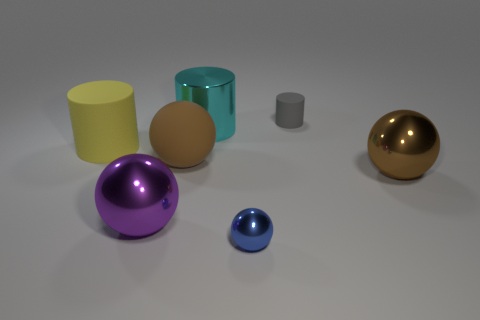The metallic thing that is the same color as the rubber sphere is what shape?
Your answer should be compact. Sphere. Are there more gray rubber cylinders to the right of the tiny gray object than tiny gray matte cylinders?
Offer a terse response. No. How many gray metallic balls are the same size as the cyan thing?
Offer a very short reply. 0. There is a metal ball that is the same color as the large rubber sphere; what is its size?
Keep it short and to the point. Large. How many objects are small metallic objects or large rubber things right of the big yellow rubber object?
Give a very brief answer. 2. The thing that is both to the right of the tiny blue shiny ball and in front of the large matte ball is what color?
Make the answer very short. Brown. Does the metal cylinder have the same size as the purple ball?
Your response must be concise. Yes. There is a large metallic sphere that is on the left side of the blue metal ball; what color is it?
Provide a short and direct response. Purple. Are there any other small rubber cylinders of the same color as the small cylinder?
Your answer should be very brief. No. What color is the other cylinder that is the same size as the cyan shiny cylinder?
Offer a very short reply. Yellow. 